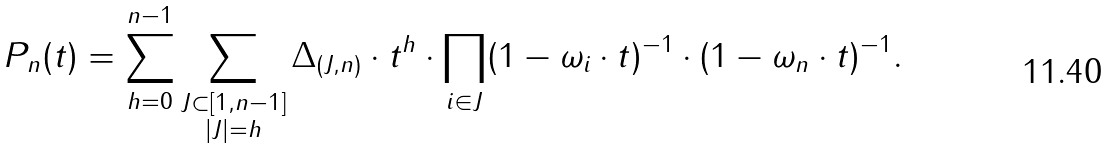Convert formula to latex. <formula><loc_0><loc_0><loc_500><loc_500>P _ { n } ( t ) = \sum _ { h = 0 } ^ { n - 1 } \sum _ { \substack { J \subset [ 1 , n - 1 ] \\ | J | = h } } \Delta _ { ( J , n ) } \cdot t ^ { h } \cdot \prod _ { i \in J } ( 1 - \omega _ { i } \cdot t ) ^ { - 1 } \cdot ( 1 - \omega _ { n } \cdot t ) ^ { - 1 } .</formula> 